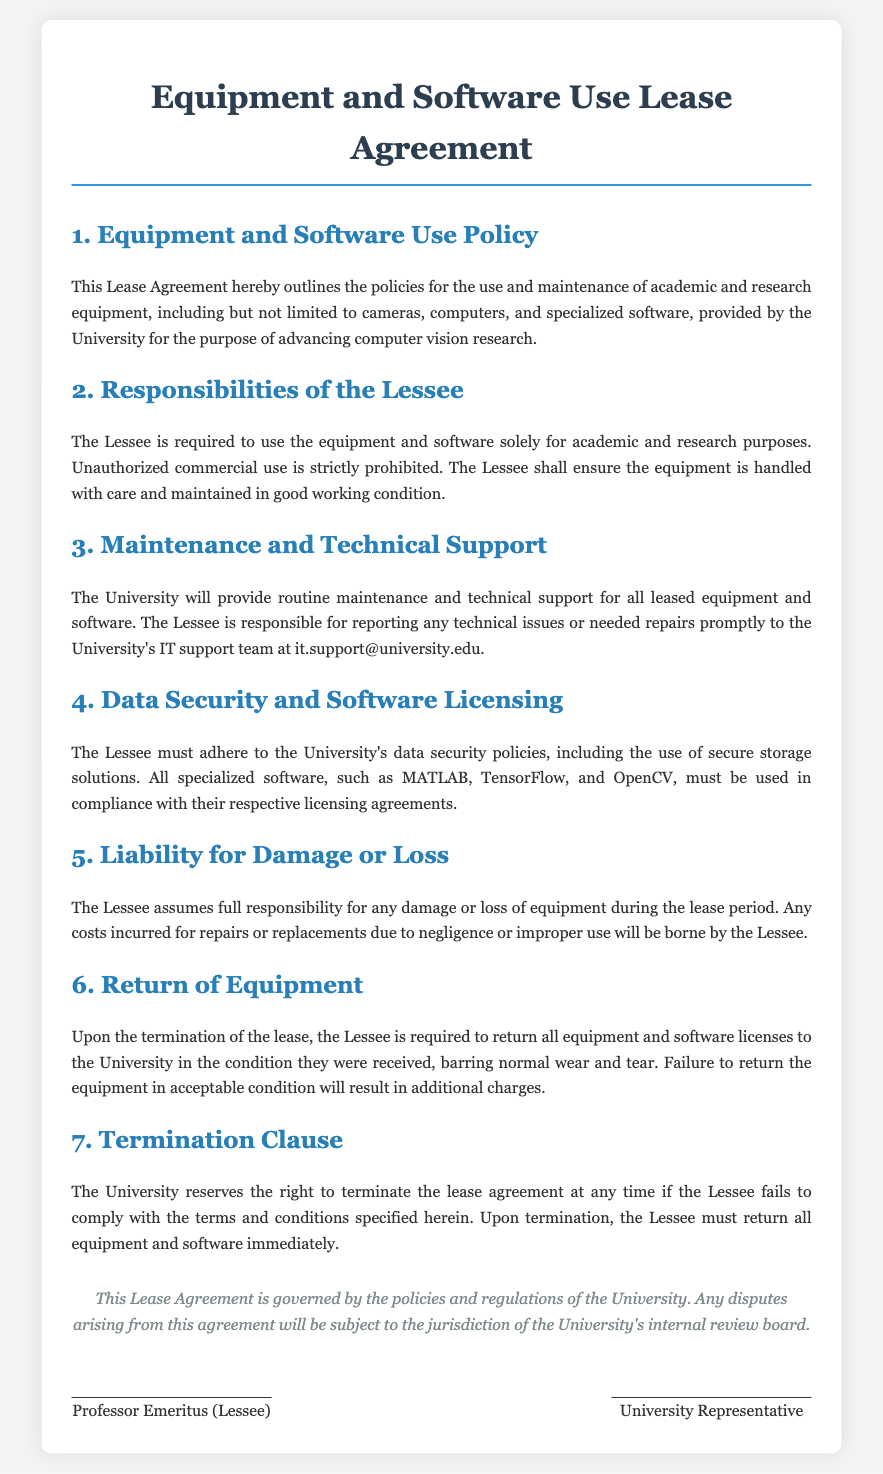What is the purpose of the Lease Agreement? The Lease Agreement outlines the policies for the use and maintenance of academic and research equipment provided by the University.
Answer: academic and research equipment Who is responsible for reporting technical issues? The Lessee is responsible for reporting any technical issues or needed repairs to the University's IT support team.
Answer: Lessee What types of software must be used in compliance with licensing agreements? The types of software include specialized software such as MATLAB, TensorFlow, and OpenCV.
Answer: MATLAB, TensorFlow, and OpenCV What happens if the Lessee fails to return the equipment in acceptable condition? Failure to return the equipment in acceptable condition will result in additional charges.
Answer: additional charges What must the Lessee ensure regarding the equipment? The Lessee must ensure that the equipment is handled with care and maintained in good working condition.
Answer: handled with care What can trigger the University's termination of the lease agreement? The University can terminate the lease if the Lessee fails to comply with the terms and conditions specified in the agreement.
Answer: compliance with the terms What is the Lessee's responsibility concerning damage or loss? The Lessee assumes full responsibility for any damage or loss of equipment during the lease period.
Answer: full responsibility What is the Lessee required to do upon termination of the lease? The Lessee is required to return all equipment and software licenses to the University.
Answer: return all equipment What will the University provide for the leased equipment? The University will provide routine maintenance and technical support for all leased equipment and software.
Answer: routine maintenance and technical support 